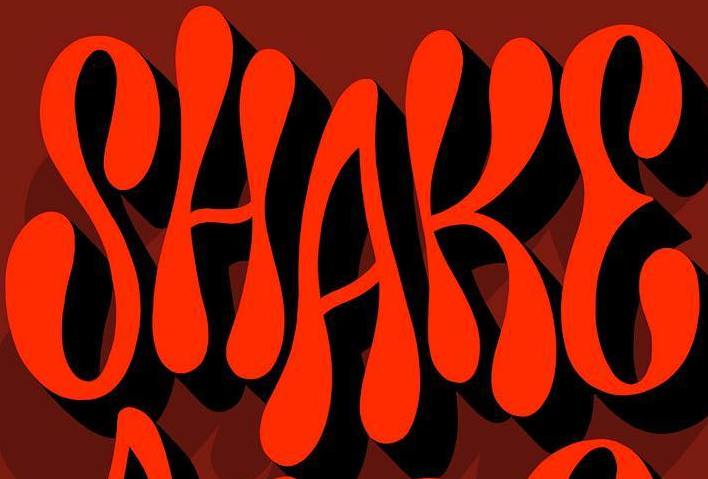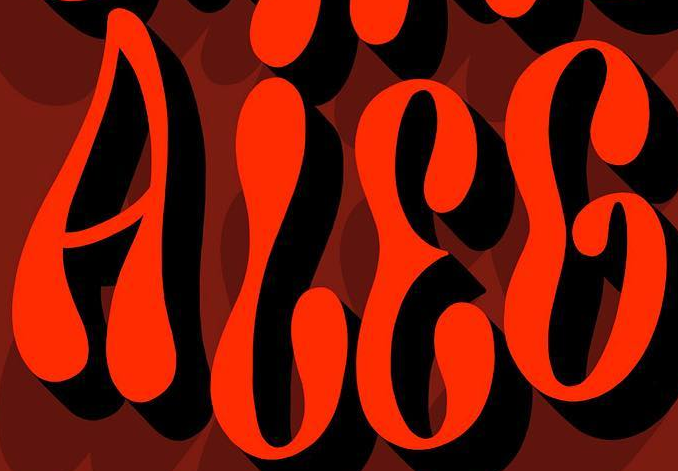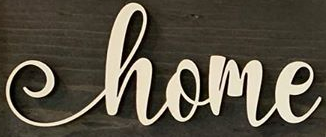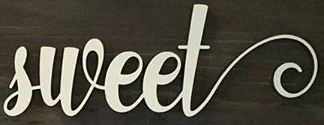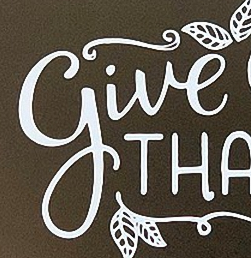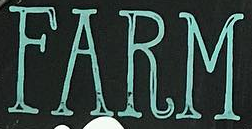Read the text content from these images in order, separated by a semicolon. SHAKE; ALEG; home; sweet; give; FARM 